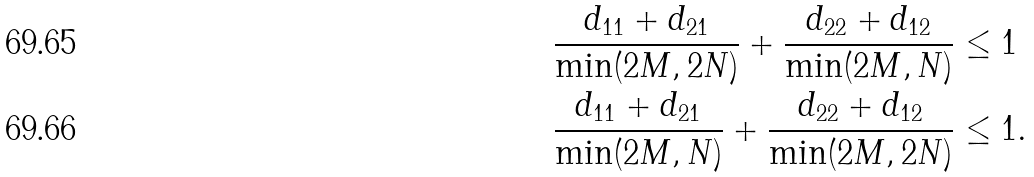<formula> <loc_0><loc_0><loc_500><loc_500>& \frac { d _ { 1 1 } + d _ { 2 1 } } { \min ( 2 M , 2 N ) } + \frac { d _ { 2 2 } + d _ { 1 2 } } { \min ( 2 M , N ) } \leq 1 \\ & \frac { d _ { 1 1 } + d _ { 2 1 } } { \min ( 2 M , N ) } + \frac { d _ { 2 2 } + d _ { 1 2 } } { \min ( 2 M , 2 N ) } \leq 1 .</formula> 